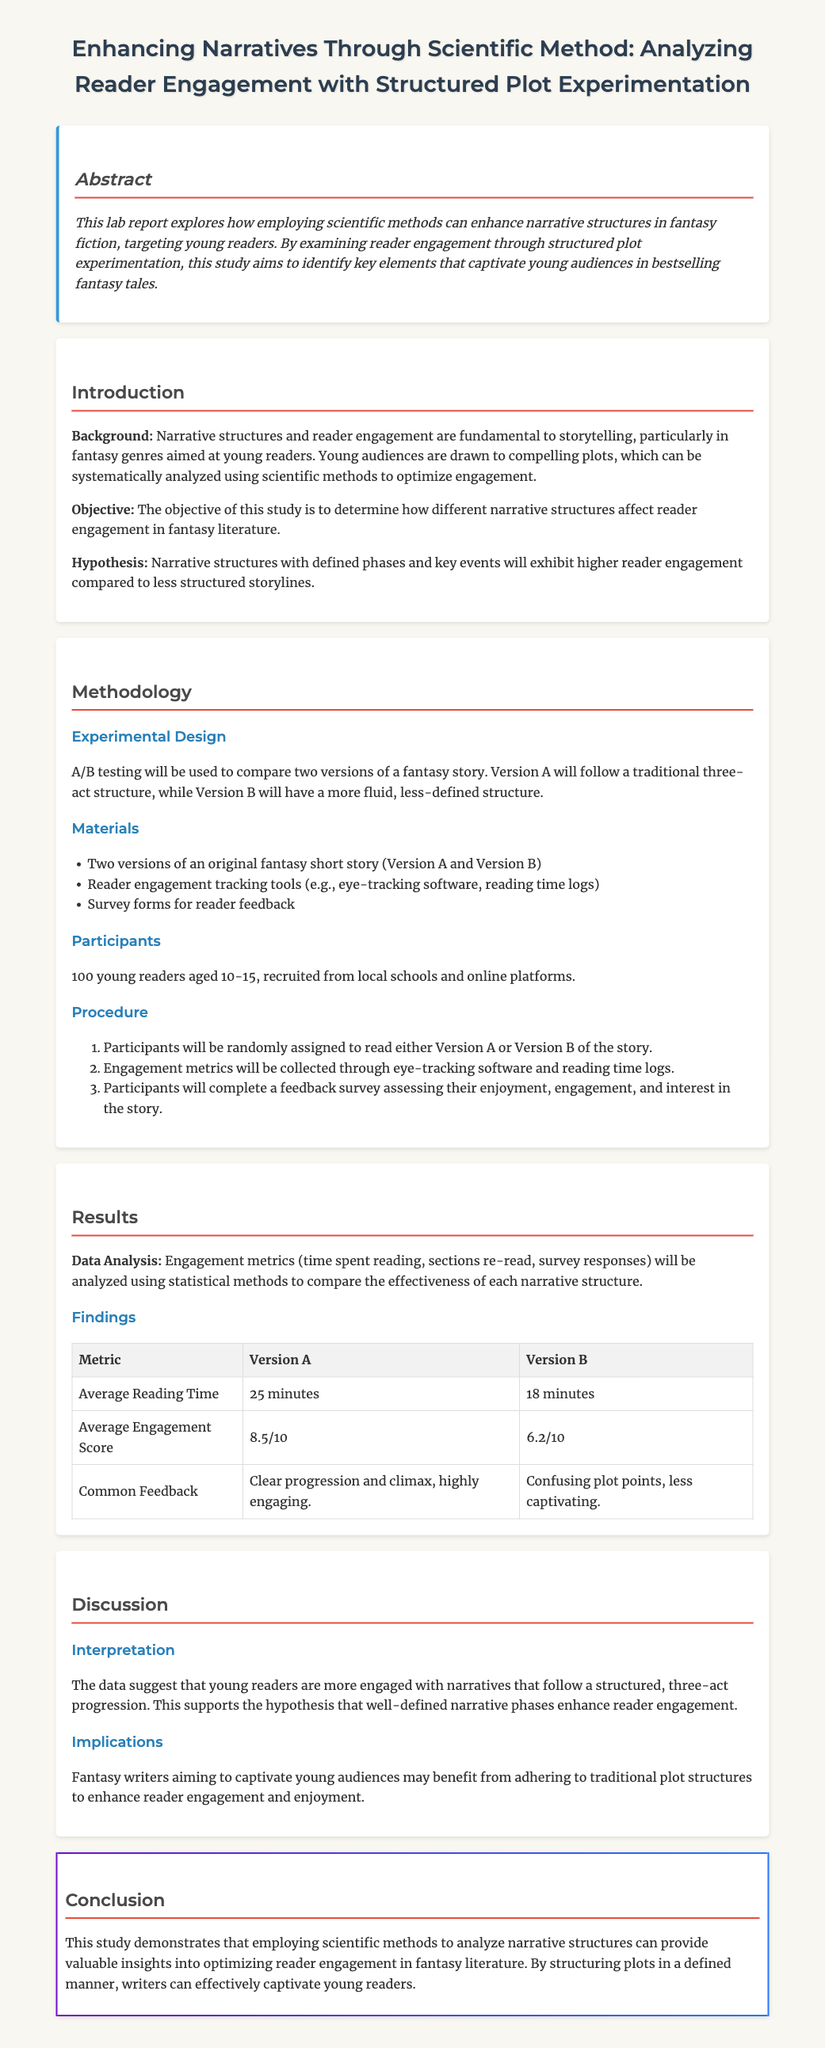What is the main objective of the study? The objective of this study is to determine how different narrative structures affect reader engagement in fantasy literature.
Answer: To determine how different narrative structures affect reader engagement How many young readers participated in the study? The number of participants is specified in the methodology section, which indicates 100 young readers participated.
Answer: 100 young readers What was the average reading time for Version A? The average reading time for Version A is provided in the results section, which states it is 25 minutes.
Answer: 25 minutes What type of experimental design was used in the study? The methodology outlines that A/B testing was used to compare two versions of a fantasy story.
Answer: A/B testing What common feedback was received for Version B? The common feedback from participants for Version B mentioned in the results section is that it had confusing plot points.
Answer: Confusing plot points What was the average engagement score for Version A? The engagement score for Version A is detailed in the results section, which indicates it was 8.5 out of 10.
Answer: 8.5/10 What hypothesis was tested in the study? The hypothesis, as stated in the introduction, focuses on narrative structures exhibiting higher reader engagement compared to less structured storylines.
Answer: Higher reader engagement for structured narratives What were the implications of the findings? The implications of the findings suggest that fantasy writers may benefit from adhering to traditional plot structures to enhance reader engagement.
Answer: Adhering to traditional plot structures 